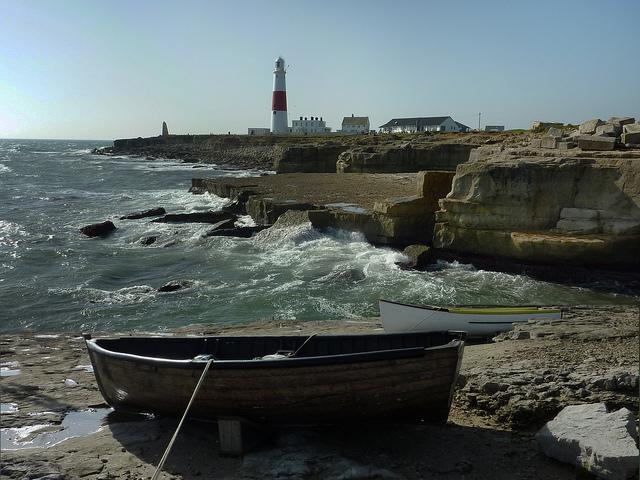Is there a power boat?
Keep it brief. No. Are there buildings in the water body?
Write a very short answer. No. What color is the water?
Give a very brief answer. Blue. 